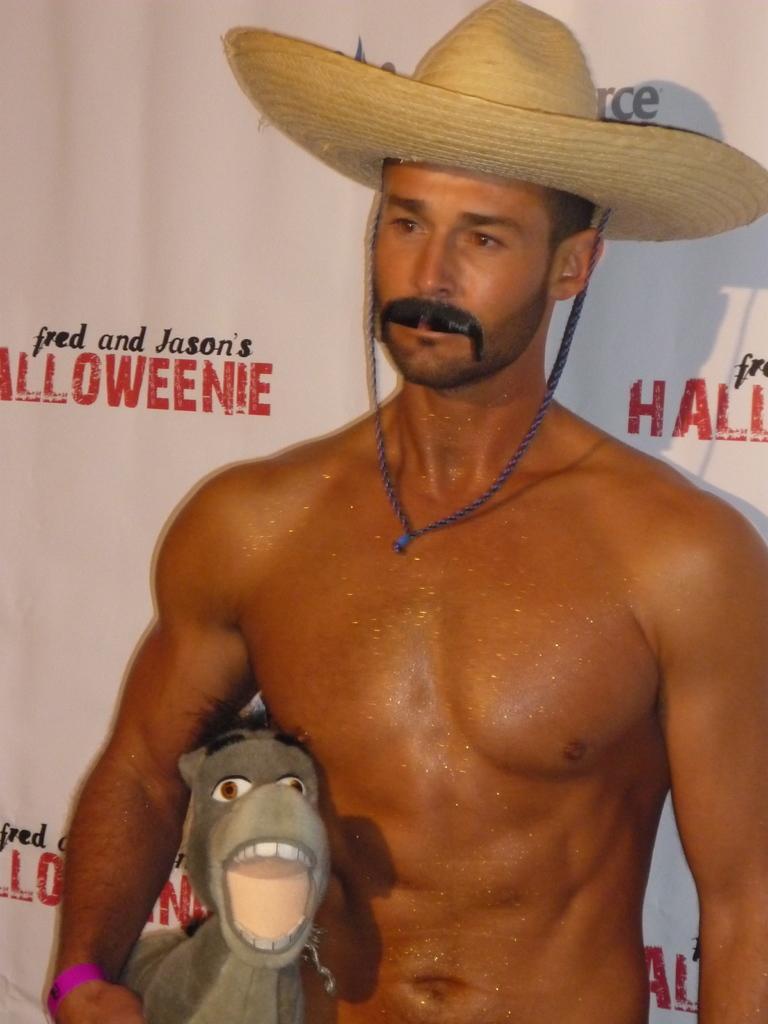Please provide a concise description of this image. In this image there is a man standing wearing a hat and holding a toy in his hand, in the background there is a poster, on that poster there is some text. 